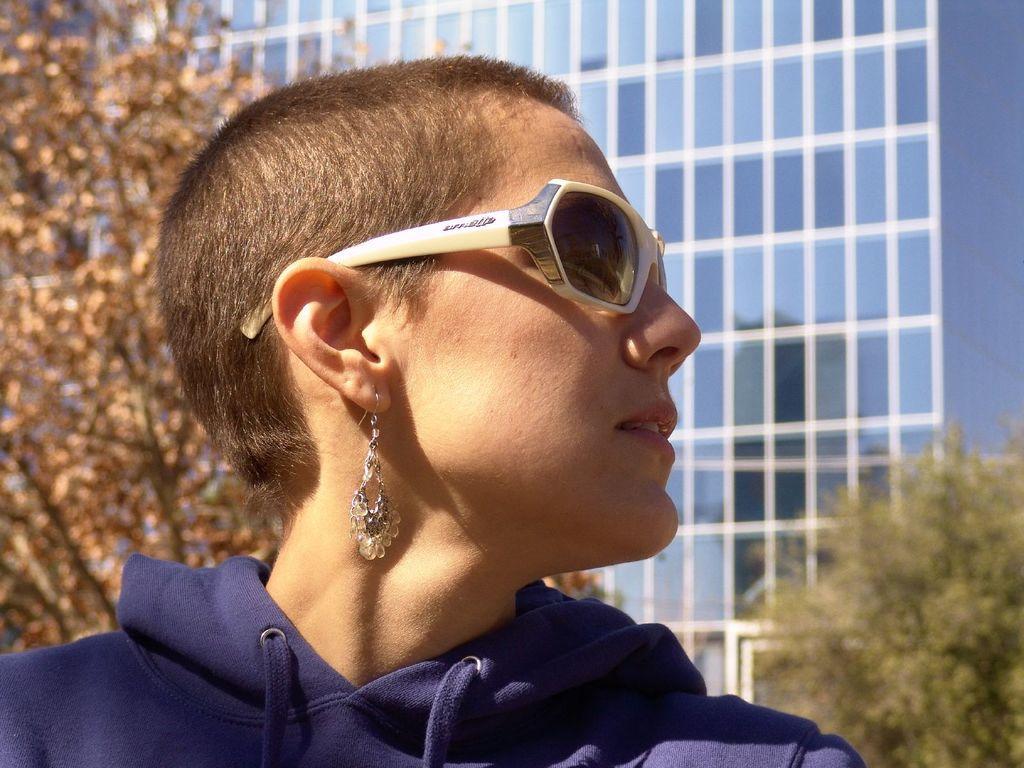Please provide a concise description of this image. In this picture I can see a woman, she is wearing sunglasses and I can see a building and couple of trees in the back. 